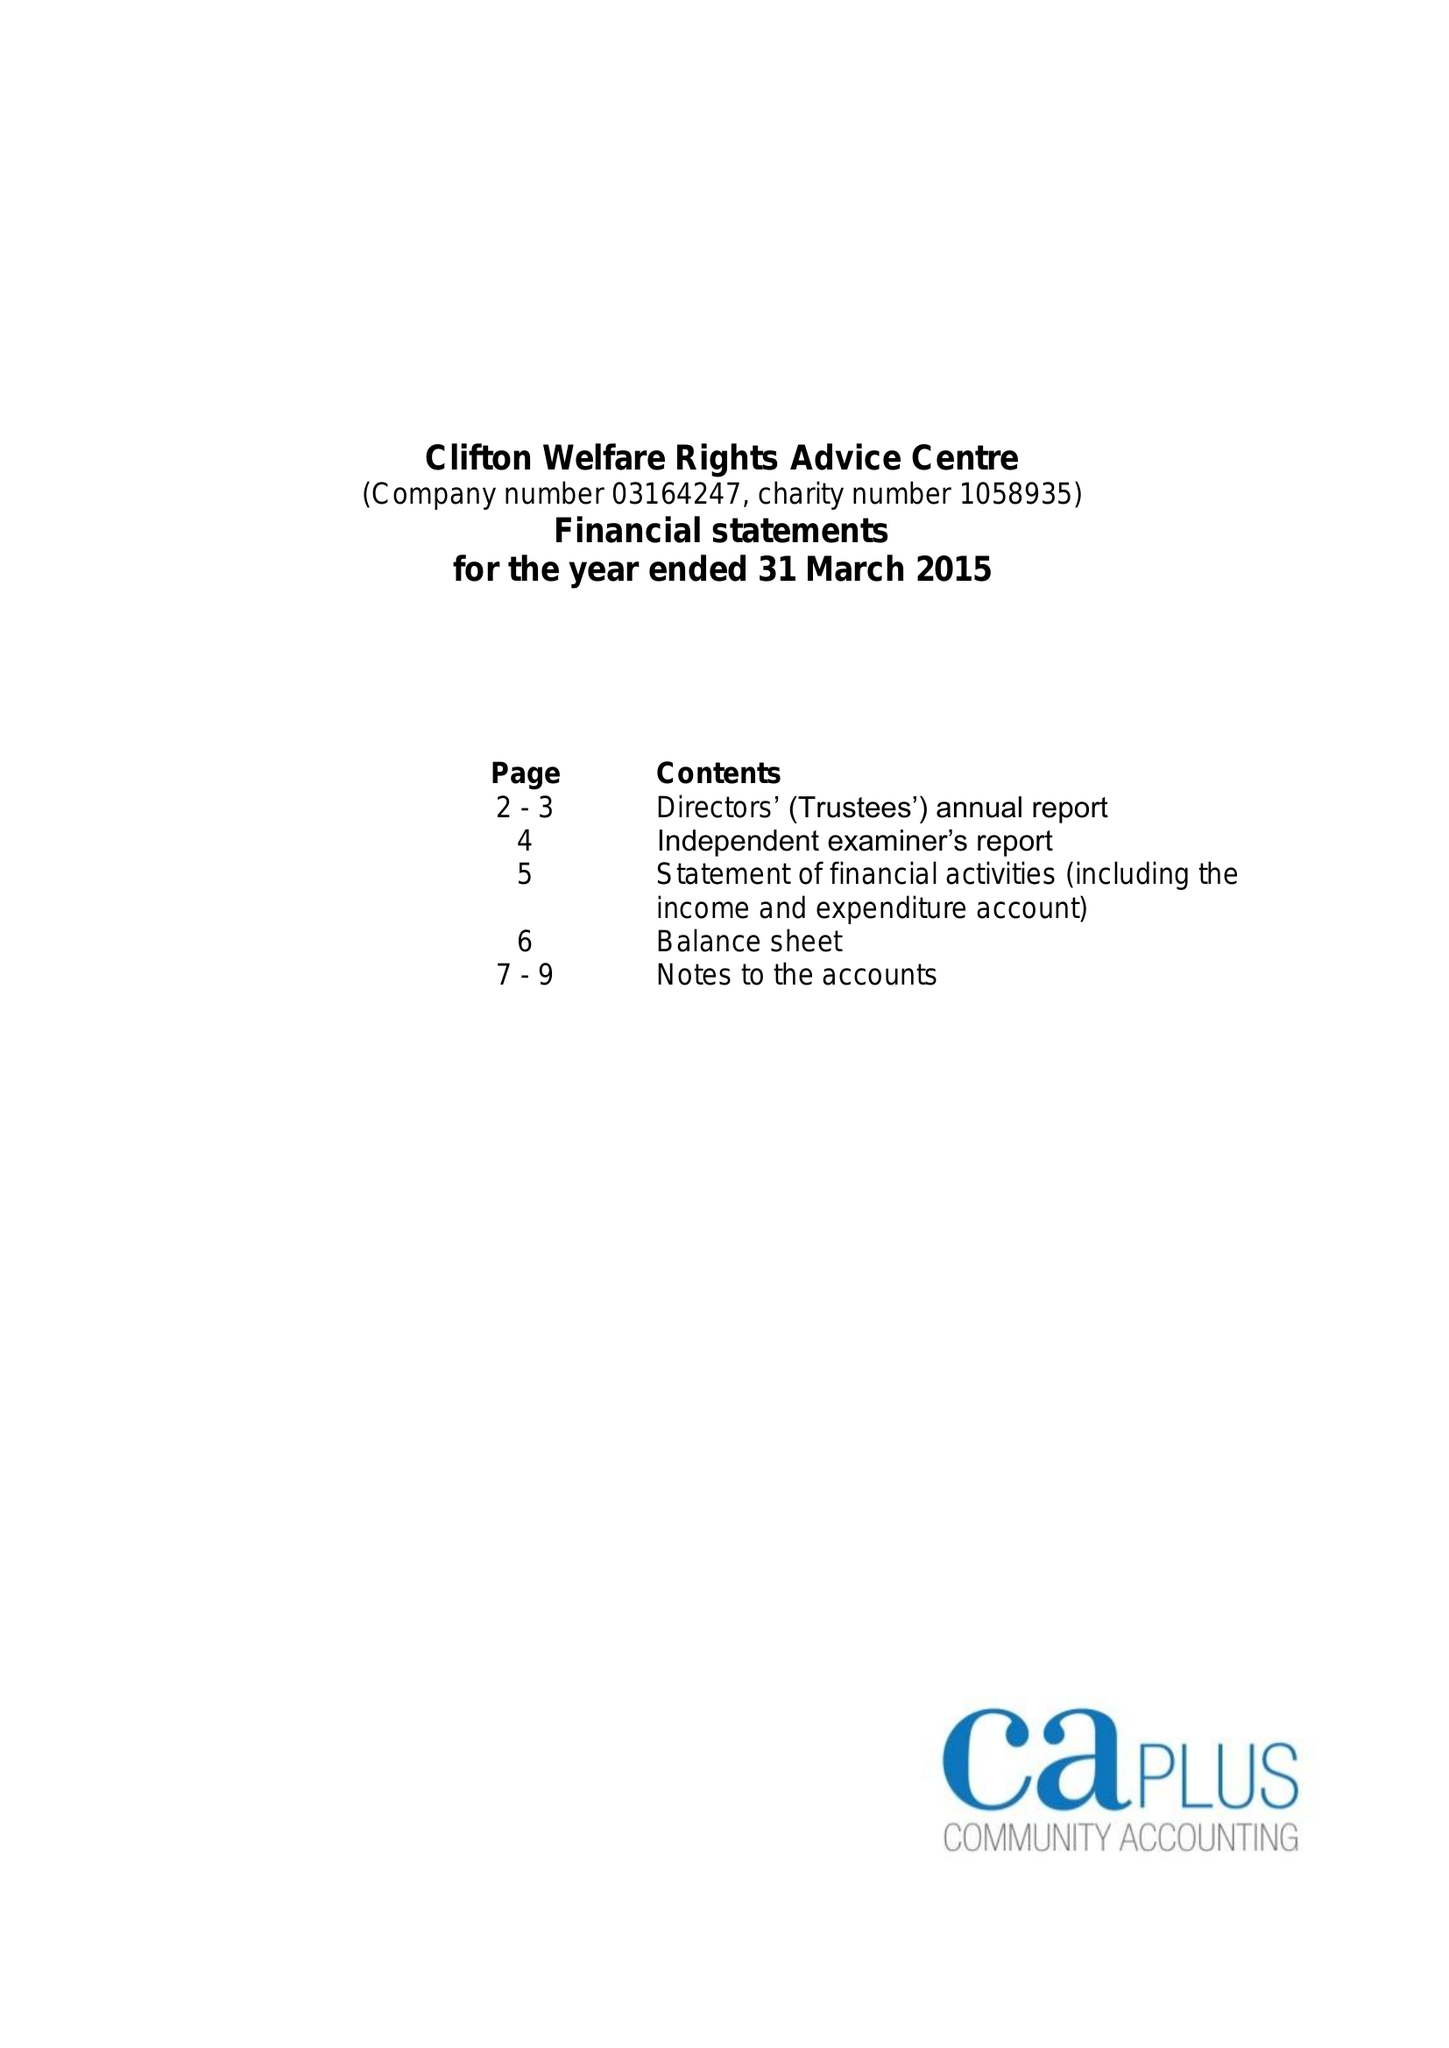What is the value for the address__street_line?
Answer the question using a single word or phrase. SOUTHCHURCH DRIVE 